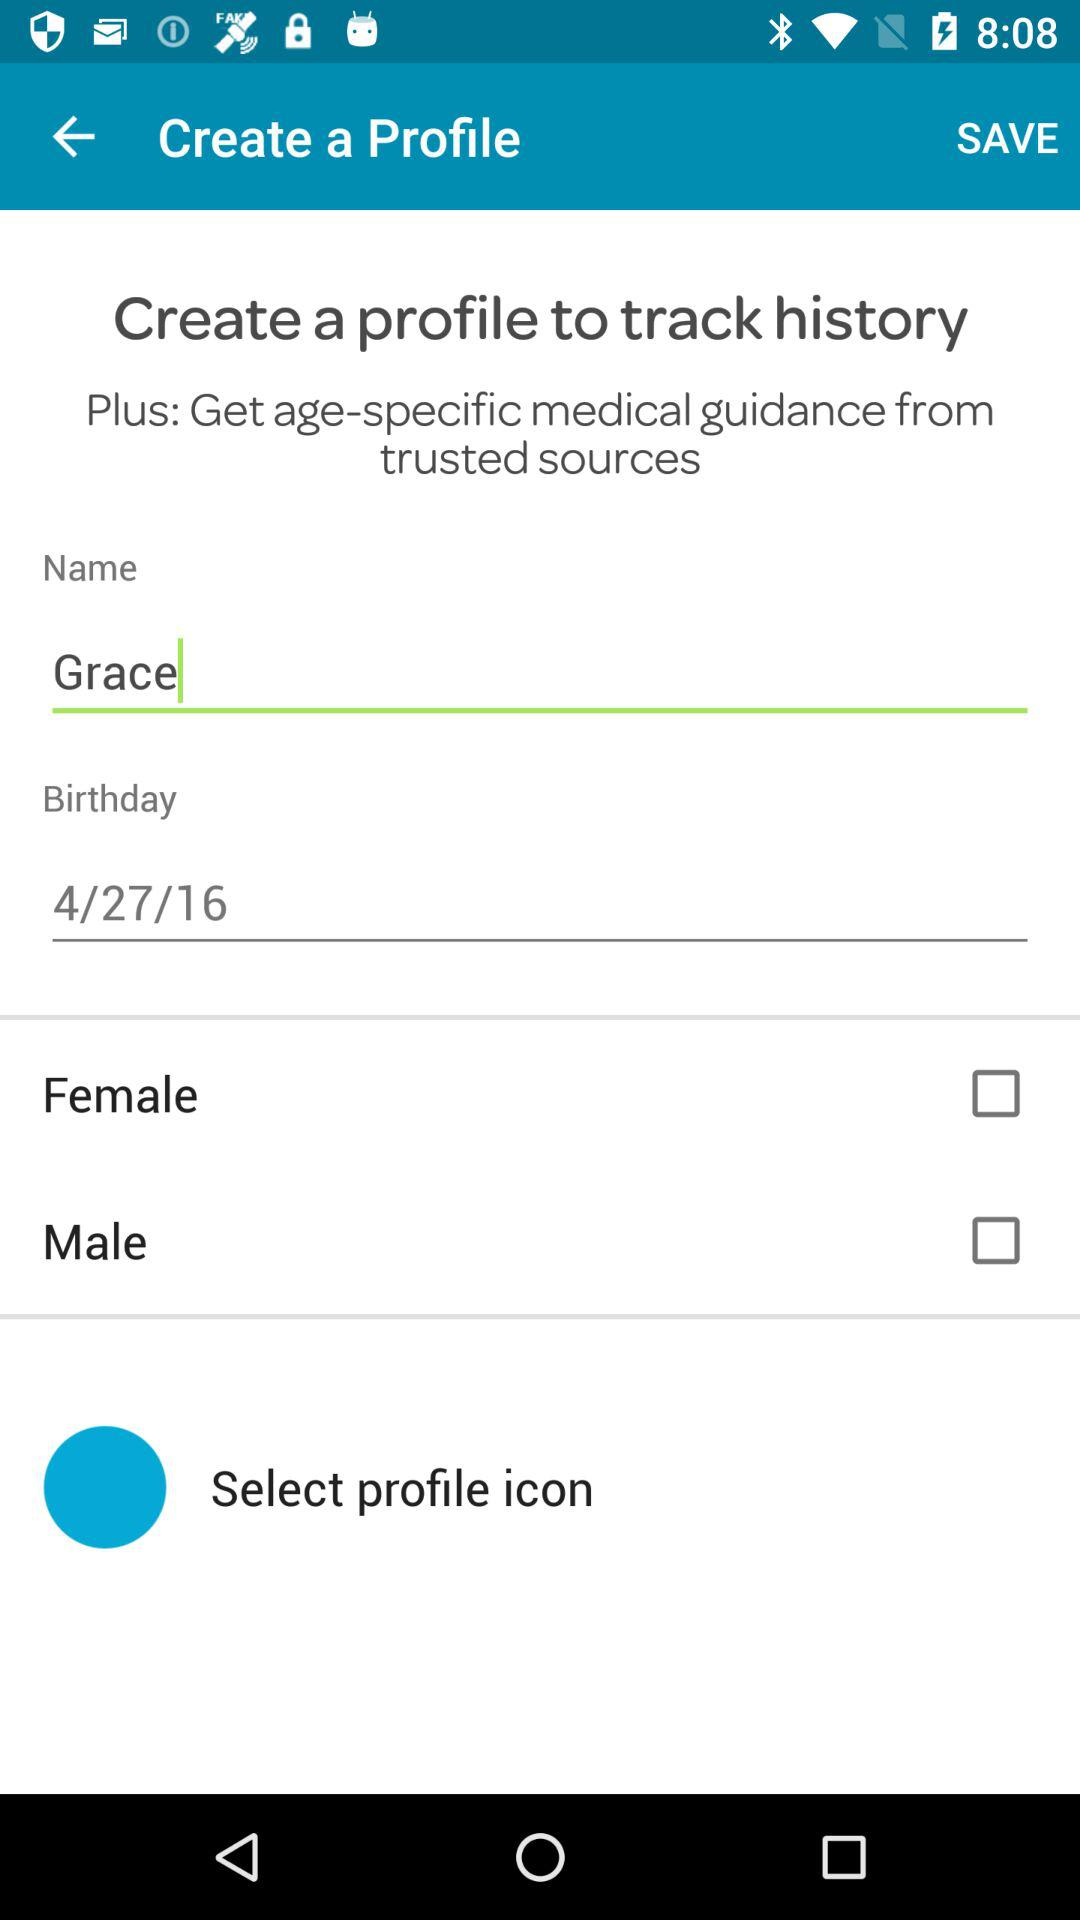What's the name of the user? The name of the user is "Grace". 